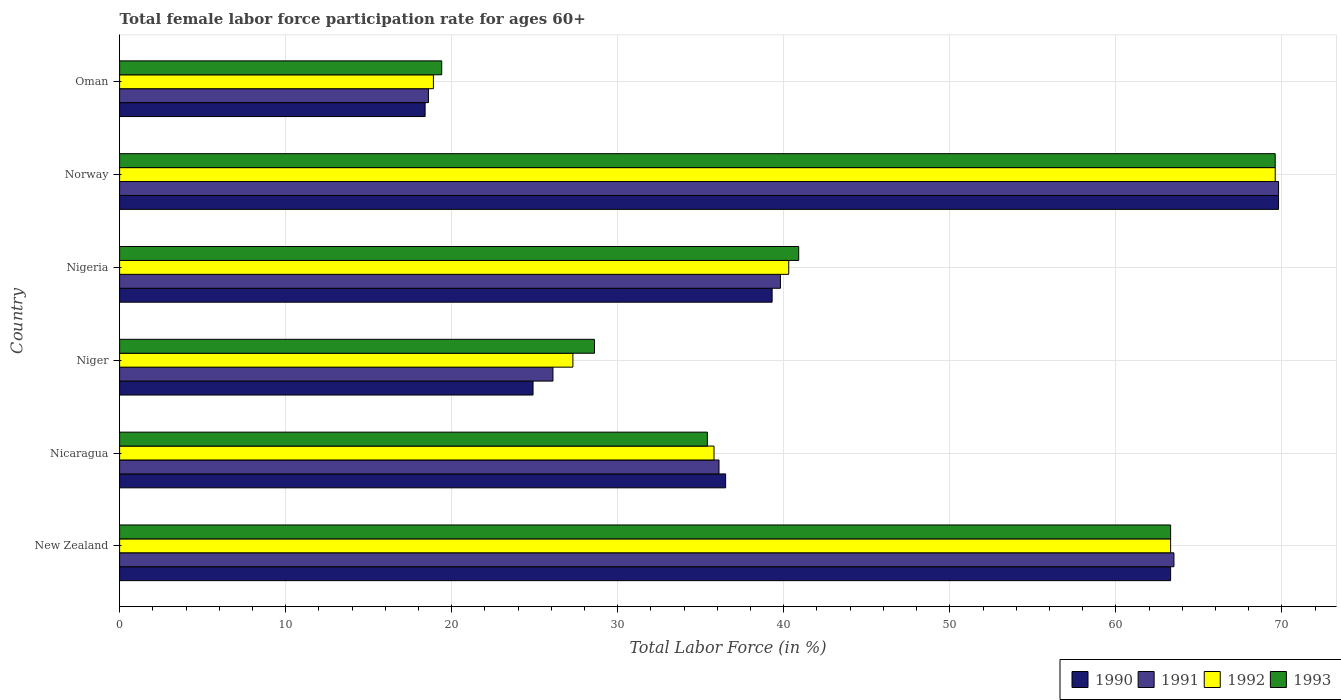Are the number of bars per tick equal to the number of legend labels?
Your answer should be very brief. Yes. How many bars are there on the 4th tick from the top?
Your answer should be very brief. 4. How many bars are there on the 1st tick from the bottom?
Offer a terse response. 4. What is the label of the 1st group of bars from the top?
Ensure brevity in your answer.  Oman. In how many cases, is the number of bars for a given country not equal to the number of legend labels?
Your response must be concise. 0. What is the female labor force participation rate in 1993 in Norway?
Provide a succinct answer. 69.6. Across all countries, what is the maximum female labor force participation rate in 1991?
Provide a succinct answer. 69.8. Across all countries, what is the minimum female labor force participation rate in 1993?
Provide a short and direct response. 19.4. In which country was the female labor force participation rate in 1990 minimum?
Your response must be concise. Oman. What is the total female labor force participation rate in 1991 in the graph?
Your answer should be very brief. 253.9. What is the difference between the female labor force participation rate in 1992 in New Zealand and that in Oman?
Make the answer very short. 44.4. What is the difference between the female labor force participation rate in 1993 in New Zealand and the female labor force participation rate in 1990 in Norway?
Your answer should be very brief. -6.5. What is the average female labor force participation rate in 1993 per country?
Provide a short and direct response. 42.87. What is the difference between the female labor force participation rate in 1993 and female labor force participation rate in 1992 in Nicaragua?
Provide a succinct answer. -0.4. In how many countries, is the female labor force participation rate in 1990 greater than 2 %?
Give a very brief answer. 6. What is the ratio of the female labor force participation rate in 1993 in Niger to that in Nigeria?
Provide a short and direct response. 0.7. Is the female labor force participation rate in 1992 in Niger less than that in Oman?
Your answer should be very brief. No. Is the difference between the female labor force participation rate in 1993 in Norway and Oman greater than the difference between the female labor force participation rate in 1992 in Norway and Oman?
Provide a succinct answer. No. What is the difference between the highest and the second highest female labor force participation rate in 1993?
Offer a very short reply. 6.3. What is the difference between the highest and the lowest female labor force participation rate in 1990?
Keep it short and to the point. 51.4. Is the sum of the female labor force participation rate in 1990 in New Zealand and Oman greater than the maximum female labor force participation rate in 1993 across all countries?
Ensure brevity in your answer.  Yes. Is it the case that in every country, the sum of the female labor force participation rate in 1991 and female labor force participation rate in 1990 is greater than the sum of female labor force participation rate in 1993 and female labor force participation rate in 1992?
Keep it short and to the point. No. What does the 1st bar from the top in Nicaragua represents?
Provide a short and direct response. 1993. How many bars are there?
Your answer should be compact. 24. How many countries are there in the graph?
Your answer should be very brief. 6. Where does the legend appear in the graph?
Your response must be concise. Bottom right. How many legend labels are there?
Your answer should be very brief. 4. What is the title of the graph?
Offer a terse response. Total female labor force participation rate for ages 60+. Does "1967" appear as one of the legend labels in the graph?
Offer a very short reply. No. What is the label or title of the X-axis?
Make the answer very short. Total Labor Force (in %). What is the label or title of the Y-axis?
Ensure brevity in your answer.  Country. What is the Total Labor Force (in %) of 1990 in New Zealand?
Provide a succinct answer. 63.3. What is the Total Labor Force (in %) in 1991 in New Zealand?
Ensure brevity in your answer.  63.5. What is the Total Labor Force (in %) in 1992 in New Zealand?
Offer a very short reply. 63.3. What is the Total Labor Force (in %) of 1993 in New Zealand?
Make the answer very short. 63.3. What is the Total Labor Force (in %) of 1990 in Nicaragua?
Offer a very short reply. 36.5. What is the Total Labor Force (in %) of 1991 in Nicaragua?
Your answer should be very brief. 36.1. What is the Total Labor Force (in %) in 1992 in Nicaragua?
Ensure brevity in your answer.  35.8. What is the Total Labor Force (in %) in 1993 in Nicaragua?
Your answer should be compact. 35.4. What is the Total Labor Force (in %) in 1990 in Niger?
Keep it short and to the point. 24.9. What is the Total Labor Force (in %) of 1991 in Niger?
Your response must be concise. 26.1. What is the Total Labor Force (in %) in 1992 in Niger?
Ensure brevity in your answer.  27.3. What is the Total Labor Force (in %) in 1993 in Niger?
Ensure brevity in your answer.  28.6. What is the Total Labor Force (in %) of 1990 in Nigeria?
Give a very brief answer. 39.3. What is the Total Labor Force (in %) of 1991 in Nigeria?
Offer a very short reply. 39.8. What is the Total Labor Force (in %) in 1992 in Nigeria?
Your answer should be compact. 40.3. What is the Total Labor Force (in %) of 1993 in Nigeria?
Your answer should be very brief. 40.9. What is the Total Labor Force (in %) in 1990 in Norway?
Offer a terse response. 69.8. What is the Total Labor Force (in %) in 1991 in Norway?
Ensure brevity in your answer.  69.8. What is the Total Labor Force (in %) in 1992 in Norway?
Make the answer very short. 69.6. What is the Total Labor Force (in %) of 1993 in Norway?
Your answer should be compact. 69.6. What is the Total Labor Force (in %) in 1990 in Oman?
Your response must be concise. 18.4. What is the Total Labor Force (in %) of 1991 in Oman?
Provide a short and direct response. 18.6. What is the Total Labor Force (in %) in 1992 in Oman?
Keep it short and to the point. 18.9. What is the Total Labor Force (in %) of 1993 in Oman?
Give a very brief answer. 19.4. Across all countries, what is the maximum Total Labor Force (in %) in 1990?
Your response must be concise. 69.8. Across all countries, what is the maximum Total Labor Force (in %) of 1991?
Keep it short and to the point. 69.8. Across all countries, what is the maximum Total Labor Force (in %) in 1992?
Give a very brief answer. 69.6. Across all countries, what is the maximum Total Labor Force (in %) in 1993?
Your answer should be compact. 69.6. Across all countries, what is the minimum Total Labor Force (in %) in 1990?
Your answer should be very brief. 18.4. Across all countries, what is the minimum Total Labor Force (in %) in 1991?
Your answer should be very brief. 18.6. Across all countries, what is the minimum Total Labor Force (in %) of 1992?
Your response must be concise. 18.9. Across all countries, what is the minimum Total Labor Force (in %) in 1993?
Ensure brevity in your answer.  19.4. What is the total Total Labor Force (in %) of 1990 in the graph?
Your answer should be compact. 252.2. What is the total Total Labor Force (in %) of 1991 in the graph?
Offer a terse response. 253.9. What is the total Total Labor Force (in %) in 1992 in the graph?
Provide a succinct answer. 255.2. What is the total Total Labor Force (in %) of 1993 in the graph?
Your answer should be very brief. 257.2. What is the difference between the Total Labor Force (in %) of 1990 in New Zealand and that in Nicaragua?
Provide a short and direct response. 26.8. What is the difference between the Total Labor Force (in %) of 1991 in New Zealand and that in Nicaragua?
Provide a succinct answer. 27.4. What is the difference between the Total Labor Force (in %) of 1993 in New Zealand and that in Nicaragua?
Make the answer very short. 27.9. What is the difference between the Total Labor Force (in %) of 1990 in New Zealand and that in Niger?
Offer a very short reply. 38.4. What is the difference between the Total Labor Force (in %) in 1991 in New Zealand and that in Niger?
Your answer should be very brief. 37.4. What is the difference between the Total Labor Force (in %) in 1993 in New Zealand and that in Niger?
Make the answer very short. 34.7. What is the difference between the Total Labor Force (in %) of 1990 in New Zealand and that in Nigeria?
Your response must be concise. 24. What is the difference between the Total Labor Force (in %) of 1991 in New Zealand and that in Nigeria?
Your answer should be very brief. 23.7. What is the difference between the Total Labor Force (in %) of 1992 in New Zealand and that in Nigeria?
Ensure brevity in your answer.  23. What is the difference between the Total Labor Force (in %) of 1993 in New Zealand and that in Nigeria?
Make the answer very short. 22.4. What is the difference between the Total Labor Force (in %) in 1993 in New Zealand and that in Norway?
Offer a very short reply. -6.3. What is the difference between the Total Labor Force (in %) in 1990 in New Zealand and that in Oman?
Make the answer very short. 44.9. What is the difference between the Total Labor Force (in %) in 1991 in New Zealand and that in Oman?
Your response must be concise. 44.9. What is the difference between the Total Labor Force (in %) in 1992 in New Zealand and that in Oman?
Provide a succinct answer. 44.4. What is the difference between the Total Labor Force (in %) in 1993 in New Zealand and that in Oman?
Offer a very short reply. 43.9. What is the difference between the Total Labor Force (in %) in 1990 in Nicaragua and that in Nigeria?
Offer a terse response. -2.8. What is the difference between the Total Labor Force (in %) in 1990 in Nicaragua and that in Norway?
Keep it short and to the point. -33.3. What is the difference between the Total Labor Force (in %) of 1991 in Nicaragua and that in Norway?
Your answer should be compact. -33.7. What is the difference between the Total Labor Force (in %) of 1992 in Nicaragua and that in Norway?
Your answer should be very brief. -33.8. What is the difference between the Total Labor Force (in %) of 1993 in Nicaragua and that in Norway?
Your answer should be compact. -34.2. What is the difference between the Total Labor Force (in %) in 1990 in Niger and that in Nigeria?
Offer a terse response. -14.4. What is the difference between the Total Labor Force (in %) in 1991 in Niger and that in Nigeria?
Make the answer very short. -13.7. What is the difference between the Total Labor Force (in %) in 1990 in Niger and that in Norway?
Give a very brief answer. -44.9. What is the difference between the Total Labor Force (in %) of 1991 in Niger and that in Norway?
Provide a short and direct response. -43.7. What is the difference between the Total Labor Force (in %) of 1992 in Niger and that in Norway?
Keep it short and to the point. -42.3. What is the difference between the Total Labor Force (in %) of 1993 in Niger and that in Norway?
Your answer should be very brief. -41. What is the difference between the Total Labor Force (in %) in 1990 in Niger and that in Oman?
Give a very brief answer. 6.5. What is the difference between the Total Labor Force (in %) in 1991 in Niger and that in Oman?
Your response must be concise. 7.5. What is the difference between the Total Labor Force (in %) of 1992 in Niger and that in Oman?
Ensure brevity in your answer.  8.4. What is the difference between the Total Labor Force (in %) of 1990 in Nigeria and that in Norway?
Provide a succinct answer. -30.5. What is the difference between the Total Labor Force (in %) of 1992 in Nigeria and that in Norway?
Your response must be concise. -29.3. What is the difference between the Total Labor Force (in %) of 1993 in Nigeria and that in Norway?
Your response must be concise. -28.7. What is the difference between the Total Labor Force (in %) in 1990 in Nigeria and that in Oman?
Offer a terse response. 20.9. What is the difference between the Total Labor Force (in %) in 1991 in Nigeria and that in Oman?
Provide a short and direct response. 21.2. What is the difference between the Total Labor Force (in %) in 1992 in Nigeria and that in Oman?
Offer a terse response. 21.4. What is the difference between the Total Labor Force (in %) of 1990 in Norway and that in Oman?
Your answer should be very brief. 51.4. What is the difference between the Total Labor Force (in %) in 1991 in Norway and that in Oman?
Provide a short and direct response. 51.2. What is the difference between the Total Labor Force (in %) in 1992 in Norway and that in Oman?
Offer a terse response. 50.7. What is the difference between the Total Labor Force (in %) of 1993 in Norway and that in Oman?
Provide a succinct answer. 50.2. What is the difference between the Total Labor Force (in %) of 1990 in New Zealand and the Total Labor Force (in %) of 1991 in Nicaragua?
Keep it short and to the point. 27.2. What is the difference between the Total Labor Force (in %) of 1990 in New Zealand and the Total Labor Force (in %) of 1992 in Nicaragua?
Keep it short and to the point. 27.5. What is the difference between the Total Labor Force (in %) in 1990 in New Zealand and the Total Labor Force (in %) in 1993 in Nicaragua?
Keep it short and to the point. 27.9. What is the difference between the Total Labor Force (in %) of 1991 in New Zealand and the Total Labor Force (in %) of 1992 in Nicaragua?
Ensure brevity in your answer.  27.7. What is the difference between the Total Labor Force (in %) in 1991 in New Zealand and the Total Labor Force (in %) in 1993 in Nicaragua?
Keep it short and to the point. 28.1. What is the difference between the Total Labor Force (in %) in 1992 in New Zealand and the Total Labor Force (in %) in 1993 in Nicaragua?
Your answer should be compact. 27.9. What is the difference between the Total Labor Force (in %) of 1990 in New Zealand and the Total Labor Force (in %) of 1991 in Niger?
Your response must be concise. 37.2. What is the difference between the Total Labor Force (in %) of 1990 in New Zealand and the Total Labor Force (in %) of 1993 in Niger?
Offer a terse response. 34.7. What is the difference between the Total Labor Force (in %) of 1991 in New Zealand and the Total Labor Force (in %) of 1992 in Niger?
Your response must be concise. 36.2. What is the difference between the Total Labor Force (in %) of 1991 in New Zealand and the Total Labor Force (in %) of 1993 in Niger?
Ensure brevity in your answer.  34.9. What is the difference between the Total Labor Force (in %) in 1992 in New Zealand and the Total Labor Force (in %) in 1993 in Niger?
Offer a very short reply. 34.7. What is the difference between the Total Labor Force (in %) of 1990 in New Zealand and the Total Labor Force (in %) of 1992 in Nigeria?
Your response must be concise. 23. What is the difference between the Total Labor Force (in %) of 1990 in New Zealand and the Total Labor Force (in %) of 1993 in Nigeria?
Your answer should be very brief. 22.4. What is the difference between the Total Labor Force (in %) of 1991 in New Zealand and the Total Labor Force (in %) of 1992 in Nigeria?
Give a very brief answer. 23.2. What is the difference between the Total Labor Force (in %) of 1991 in New Zealand and the Total Labor Force (in %) of 1993 in Nigeria?
Your answer should be very brief. 22.6. What is the difference between the Total Labor Force (in %) of 1992 in New Zealand and the Total Labor Force (in %) of 1993 in Nigeria?
Give a very brief answer. 22.4. What is the difference between the Total Labor Force (in %) in 1990 in New Zealand and the Total Labor Force (in %) in 1991 in Norway?
Your answer should be compact. -6.5. What is the difference between the Total Labor Force (in %) of 1990 in New Zealand and the Total Labor Force (in %) of 1993 in Norway?
Offer a very short reply. -6.3. What is the difference between the Total Labor Force (in %) of 1991 in New Zealand and the Total Labor Force (in %) of 1993 in Norway?
Your answer should be compact. -6.1. What is the difference between the Total Labor Force (in %) of 1990 in New Zealand and the Total Labor Force (in %) of 1991 in Oman?
Your answer should be very brief. 44.7. What is the difference between the Total Labor Force (in %) in 1990 in New Zealand and the Total Labor Force (in %) in 1992 in Oman?
Keep it short and to the point. 44.4. What is the difference between the Total Labor Force (in %) of 1990 in New Zealand and the Total Labor Force (in %) of 1993 in Oman?
Offer a terse response. 43.9. What is the difference between the Total Labor Force (in %) in 1991 in New Zealand and the Total Labor Force (in %) in 1992 in Oman?
Provide a succinct answer. 44.6. What is the difference between the Total Labor Force (in %) in 1991 in New Zealand and the Total Labor Force (in %) in 1993 in Oman?
Make the answer very short. 44.1. What is the difference between the Total Labor Force (in %) in 1992 in New Zealand and the Total Labor Force (in %) in 1993 in Oman?
Offer a terse response. 43.9. What is the difference between the Total Labor Force (in %) of 1990 in Nicaragua and the Total Labor Force (in %) of 1991 in Niger?
Ensure brevity in your answer.  10.4. What is the difference between the Total Labor Force (in %) in 1990 in Nicaragua and the Total Labor Force (in %) in 1992 in Niger?
Keep it short and to the point. 9.2. What is the difference between the Total Labor Force (in %) of 1991 in Nicaragua and the Total Labor Force (in %) of 1992 in Niger?
Your answer should be very brief. 8.8. What is the difference between the Total Labor Force (in %) of 1991 in Nicaragua and the Total Labor Force (in %) of 1993 in Niger?
Keep it short and to the point. 7.5. What is the difference between the Total Labor Force (in %) in 1990 in Nicaragua and the Total Labor Force (in %) in 1991 in Nigeria?
Make the answer very short. -3.3. What is the difference between the Total Labor Force (in %) of 1990 in Nicaragua and the Total Labor Force (in %) of 1993 in Nigeria?
Give a very brief answer. -4.4. What is the difference between the Total Labor Force (in %) in 1991 in Nicaragua and the Total Labor Force (in %) in 1993 in Nigeria?
Your answer should be very brief. -4.8. What is the difference between the Total Labor Force (in %) of 1992 in Nicaragua and the Total Labor Force (in %) of 1993 in Nigeria?
Give a very brief answer. -5.1. What is the difference between the Total Labor Force (in %) in 1990 in Nicaragua and the Total Labor Force (in %) in 1991 in Norway?
Offer a terse response. -33.3. What is the difference between the Total Labor Force (in %) in 1990 in Nicaragua and the Total Labor Force (in %) in 1992 in Norway?
Offer a terse response. -33.1. What is the difference between the Total Labor Force (in %) of 1990 in Nicaragua and the Total Labor Force (in %) of 1993 in Norway?
Offer a terse response. -33.1. What is the difference between the Total Labor Force (in %) in 1991 in Nicaragua and the Total Labor Force (in %) in 1992 in Norway?
Give a very brief answer. -33.5. What is the difference between the Total Labor Force (in %) in 1991 in Nicaragua and the Total Labor Force (in %) in 1993 in Norway?
Your response must be concise. -33.5. What is the difference between the Total Labor Force (in %) in 1992 in Nicaragua and the Total Labor Force (in %) in 1993 in Norway?
Your response must be concise. -33.8. What is the difference between the Total Labor Force (in %) of 1990 in Nicaragua and the Total Labor Force (in %) of 1991 in Oman?
Offer a terse response. 17.9. What is the difference between the Total Labor Force (in %) of 1990 in Nicaragua and the Total Labor Force (in %) of 1993 in Oman?
Your answer should be compact. 17.1. What is the difference between the Total Labor Force (in %) in 1991 in Nicaragua and the Total Labor Force (in %) in 1992 in Oman?
Your answer should be compact. 17.2. What is the difference between the Total Labor Force (in %) of 1991 in Nicaragua and the Total Labor Force (in %) of 1993 in Oman?
Provide a short and direct response. 16.7. What is the difference between the Total Labor Force (in %) in 1990 in Niger and the Total Labor Force (in %) in 1991 in Nigeria?
Give a very brief answer. -14.9. What is the difference between the Total Labor Force (in %) of 1990 in Niger and the Total Labor Force (in %) of 1992 in Nigeria?
Provide a short and direct response. -15.4. What is the difference between the Total Labor Force (in %) in 1991 in Niger and the Total Labor Force (in %) in 1993 in Nigeria?
Offer a terse response. -14.8. What is the difference between the Total Labor Force (in %) of 1992 in Niger and the Total Labor Force (in %) of 1993 in Nigeria?
Your response must be concise. -13.6. What is the difference between the Total Labor Force (in %) of 1990 in Niger and the Total Labor Force (in %) of 1991 in Norway?
Your answer should be compact. -44.9. What is the difference between the Total Labor Force (in %) in 1990 in Niger and the Total Labor Force (in %) in 1992 in Norway?
Provide a succinct answer. -44.7. What is the difference between the Total Labor Force (in %) in 1990 in Niger and the Total Labor Force (in %) in 1993 in Norway?
Offer a very short reply. -44.7. What is the difference between the Total Labor Force (in %) of 1991 in Niger and the Total Labor Force (in %) of 1992 in Norway?
Your response must be concise. -43.5. What is the difference between the Total Labor Force (in %) in 1991 in Niger and the Total Labor Force (in %) in 1993 in Norway?
Give a very brief answer. -43.5. What is the difference between the Total Labor Force (in %) in 1992 in Niger and the Total Labor Force (in %) in 1993 in Norway?
Make the answer very short. -42.3. What is the difference between the Total Labor Force (in %) of 1990 in Niger and the Total Labor Force (in %) of 1991 in Oman?
Provide a short and direct response. 6.3. What is the difference between the Total Labor Force (in %) in 1990 in Niger and the Total Labor Force (in %) in 1993 in Oman?
Offer a very short reply. 5.5. What is the difference between the Total Labor Force (in %) of 1991 in Niger and the Total Labor Force (in %) of 1992 in Oman?
Provide a short and direct response. 7.2. What is the difference between the Total Labor Force (in %) of 1990 in Nigeria and the Total Labor Force (in %) of 1991 in Norway?
Your response must be concise. -30.5. What is the difference between the Total Labor Force (in %) in 1990 in Nigeria and the Total Labor Force (in %) in 1992 in Norway?
Offer a very short reply. -30.3. What is the difference between the Total Labor Force (in %) of 1990 in Nigeria and the Total Labor Force (in %) of 1993 in Norway?
Make the answer very short. -30.3. What is the difference between the Total Labor Force (in %) in 1991 in Nigeria and the Total Labor Force (in %) in 1992 in Norway?
Give a very brief answer. -29.8. What is the difference between the Total Labor Force (in %) of 1991 in Nigeria and the Total Labor Force (in %) of 1993 in Norway?
Your answer should be very brief. -29.8. What is the difference between the Total Labor Force (in %) of 1992 in Nigeria and the Total Labor Force (in %) of 1993 in Norway?
Your answer should be compact. -29.3. What is the difference between the Total Labor Force (in %) in 1990 in Nigeria and the Total Labor Force (in %) in 1991 in Oman?
Provide a succinct answer. 20.7. What is the difference between the Total Labor Force (in %) of 1990 in Nigeria and the Total Labor Force (in %) of 1992 in Oman?
Ensure brevity in your answer.  20.4. What is the difference between the Total Labor Force (in %) of 1990 in Nigeria and the Total Labor Force (in %) of 1993 in Oman?
Offer a very short reply. 19.9. What is the difference between the Total Labor Force (in %) in 1991 in Nigeria and the Total Labor Force (in %) in 1992 in Oman?
Your response must be concise. 20.9. What is the difference between the Total Labor Force (in %) of 1991 in Nigeria and the Total Labor Force (in %) of 1993 in Oman?
Ensure brevity in your answer.  20.4. What is the difference between the Total Labor Force (in %) of 1992 in Nigeria and the Total Labor Force (in %) of 1993 in Oman?
Provide a short and direct response. 20.9. What is the difference between the Total Labor Force (in %) of 1990 in Norway and the Total Labor Force (in %) of 1991 in Oman?
Your answer should be compact. 51.2. What is the difference between the Total Labor Force (in %) in 1990 in Norway and the Total Labor Force (in %) in 1992 in Oman?
Provide a short and direct response. 50.9. What is the difference between the Total Labor Force (in %) of 1990 in Norway and the Total Labor Force (in %) of 1993 in Oman?
Keep it short and to the point. 50.4. What is the difference between the Total Labor Force (in %) of 1991 in Norway and the Total Labor Force (in %) of 1992 in Oman?
Your answer should be compact. 50.9. What is the difference between the Total Labor Force (in %) in 1991 in Norway and the Total Labor Force (in %) in 1993 in Oman?
Offer a terse response. 50.4. What is the difference between the Total Labor Force (in %) of 1992 in Norway and the Total Labor Force (in %) of 1993 in Oman?
Your response must be concise. 50.2. What is the average Total Labor Force (in %) of 1990 per country?
Give a very brief answer. 42.03. What is the average Total Labor Force (in %) in 1991 per country?
Provide a short and direct response. 42.32. What is the average Total Labor Force (in %) of 1992 per country?
Ensure brevity in your answer.  42.53. What is the average Total Labor Force (in %) in 1993 per country?
Your response must be concise. 42.87. What is the difference between the Total Labor Force (in %) in 1990 and Total Labor Force (in %) in 1991 in New Zealand?
Keep it short and to the point. -0.2. What is the difference between the Total Labor Force (in %) in 1991 and Total Labor Force (in %) in 1992 in New Zealand?
Your response must be concise. 0.2. What is the difference between the Total Labor Force (in %) in 1991 and Total Labor Force (in %) in 1993 in New Zealand?
Keep it short and to the point. 0.2. What is the difference between the Total Labor Force (in %) of 1992 and Total Labor Force (in %) of 1993 in New Zealand?
Your answer should be very brief. 0. What is the difference between the Total Labor Force (in %) in 1990 and Total Labor Force (in %) in 1991 in Nicaragua?
Keep it short and to the point. 0.4. What is the difference between the Total Labor Force (in %) of 1990 and Total Labor Force (in %) of 1993 in Nicaragua?
Offer a very short reply. 1.1. What is the difference between the Total Labor Force (in %) in 1991 and Total Labor Force (in %) in 1993 in Nicaragua?
Offer a very short reply. 0.7. What is the difference between the Total Labor Force (in %) of 1991 and Total Labor Force (in %) of 1993 in Niger?
Your answer should be compact. -2.5. What is the difference between the Total Labor Force (in %) in 1990 and Total Labor Force (in %) in 1991 in Nigeria?
Make the answer very short. -0.5. What is the difference between the Total Labor Force (in %) of 1990 and Total Labor Force (in %) of 1992 in Nigeria?
Your answer should be compact. -1. What is the difference between the Total Labor Force (in %) in 1990 and Total Labor Force (in %) in 1993 in Nigeria?
Your response must be concise. -1.6. What is the difference between the Total Labor Force (in %) in 1991 and Total Labor Force (in %) in 1992 in Nigeria?
Your answer should be compact. -0.5. What is the difference between the Total Labor Force (in %) in 1991 and Total Labor Force (in %) in 1993 in Nigeria?
Provide a succinct answer. -1.1. What is the difference between the Total Labor Force (in %) of 1992 and Total Labor Force (in %) of 1993 in Nigeria?
Provide a short and direct response. -0.6. What is the difference between the Total Labor Force (in %) of 1990 and Total Labor Force (in %) of 1991 in Norway?
Offer a terse response. 0. What is the difference between the Total Labor Force (in %) of 1990 and Total Labor Force (in %) of 1992 in Norway?
Your answer should be compact. 0.2. What is the difference between the Total Labor Force (in %) of 1990 and Total Labor Force (in %) of 1993 in Norway?
Give a very brief answer. 0.2. What is the difference between the Total Labor Force (in %) of 1991 and Total Labor Force (in %) of 1992 in Norway?
Your answer should be very brief. 0.2. What is the difference between the Total Labor Force (in %) in 1991 and Total Labor Force (in %) in 1993 in Norway?
Your answer should be compact. 0.2. What is the difference between the Total Labor Force (in %) in 1992 and Total Labor Force (in %) in 1993 in Norway?
Offer a very short reply. 0. What is the difference between the Total Labor Force (in %) of 1991 and Total Labor Force (in %) of 1992 in Oman?
Give a very brief answer. -0.3. What is the difference between the Total Labor Force (in %) of 1991 and Total Labor Force (in %) of 1993 in Oman?
Provide a succinct answer. -0.8. What is the difference between the Total Labor Force (in %) of 1992 and Total Labor Force (in %) of 1993 in Oman?
Make the answer very short. -0.5. What is the ratio of the Total Labor Force (in %) of 1990 in New Zealand to that in Nicaragua?
Offer a very short reply. 1.73. What is the ratio of the Total Labor Force (in %) of 1991 in New Zealand to that in Nicaragua?
Provide a succinct answer. 1.76. What is the ratio of the Total Labor Force (in %) of 1992 in New Zealand to that in Nicaragua?
Your answer should be very brief. 1.77. What is the ratio of the Total Labor Force (in %) of 1993 in New Zealand to that in Nicaragua?
Make the answer very short. 1.79. What is the ratio of the Total Labor Force (in %) of 1990 in New Zealand to that in Niger?
Keep it short and to the point. 2.54. What is the ratio of the Total Labor Force (in %) of 1991 in New Zealand to that in Niger?
Give a very brief answer. 2.43. What is the ratio of the Total Labor Force (in %) of 1992 in New Zealand to that in Niger?
Your answer should be compact. 2.32. What is the ratio of the Total Labor Force (in %) of 1993 in New Zealand to that in Niger?
Offer a very short reply. 2.21. What is the ratio of the Total Labor Force (in %) in 1990 in New Zealand to that in Nigeria?
Ensure brevity in your answer.  1.61. What is the ratio of the Total Labor Force (in %) of 1991 in New Zealand to that in Nigeria?
Give a very brief answer. 1.6. What is the ratio of the Total Labor Force (in %) of 1992 in New Zealand to that in Nigeria?
Give a very brief answer. 1.57. What is the ratio of the Total Labor Force (in %) in 1993 in New Zealand to that in Nigeria?
Offer a very short reply. 1.55. What is the ratio of the Total Labor Force (in %) in 1990 in New Zealand to that in Norway?
Offer a very short reply. 0.91. What is the ratio of the Total Labor Force (in %) of 1991 in New Zealand to that in Norway?
Your answer should be compact. 0.91. What is the ratio of the Total Labor Force (in %) of 1992 in New Zealand to that in Norway?
Ensure brevity in your answer.  0.91. What is the ratio of the Total Labor Force (in %) of 1993 in New Zealand to that in Norway?
Your response must be concise. 0.91. What is the ratio of the Total Labor Force (in %) in 1990 in New Zealand to that in Oman?
Keep it short and to the point. 3.44. What is the ratio of the Total Labor Force (in %) of 1991 in New Zealand to that in Oman?
Give a very brief answer. 3.41. What is the ratio of the Total Labor Force (in %) in 1992 in New Zealand to that in Oman?
Your answer should be very brief. 3.35. What is the ratio of the Total Labor Force (in %) of 1993 in New Zealand to that in Oman?
Offer a very short reply. 3.26. What is the ratio of the Total Labor Force (in %) of 1990 in Nicaragua to that in Niger?
Provide a short and direct response. 1.47. What is the ratio of the Total Labor Force (in %) in 1991 in Nicaragua to that in Niger?
Provide a short and direct response. 1.38. What is the ratio of the Total Labor Force (in %) in 1992 in Nicaragua to that in Niger?
Keep it short and to the point. 1.31. What is the ratio of the Total Labor Force (in %) in 1993 in Nicaragua to that in Niger?
Your response must be concise. 1.24. What is the ratio of the Total Labor Force (in %) in 1990 in Nicaragua to that in Nigeria?
Give a very brief answer. 0.93. What is the ratio of the Total Labor Force (in %) of 1991 in Nicaragua to that in Nigeria?
Keep it short and to the point. 0.91. What is the ratio of the Total Labor Force (in %) of 1992 in Nicaragua to that in Nigeria?
Give a very brief answer. 0.89. What is the ratio of the Total Labor Force (in %) of 1993 in Nicaragua to that in Nigeria?
Your answer should be compact. 0.87. What is the ratio of the Total Labor Force (in %) in 1990 in Nicaragua to that in Norway?
Offer a terse response. 0.52. What is the ratio of the Total Labor Force (in %) in 1991 in Nicaragua to that in Norway?
Ensure brevity in your answer.  0.52. What is the ratio of the Total Labor Force (in %) in 1992 in Nicaragua to that in Norway?
Make the answer very short. 0.51. What is the ratio of the Total Labor Force (in %) of 1993 in Nicaragua to that in Norway?
Offer a very short reply. 0.51. What is the ratio of the Total Labor Force (in %) of 1990 in Nicaragua to that in Oman?
Make the answer very short. 1.98. What is the ratio of the Total Labor Force (in %) of 1991 in Nicaragua to that in Oman?
Provide a short and direct response. 1.94. What is the ratio of the Total Labor Force (in %) in 1992 in Nicaragua to that in Oman?
Keep it short and to the point. 1.89. What is the ratio of the Total Labor Force (in %) in 1993 in Nicaragua to that in Oman?
Offer a terse response. 1.82. What is the ratio of the Total Labor Force (in %) of 1990 in Niger to that in Nigeria?
Offer a terse response. 0.63. What is the ratio of the Total Labor Force (in %) in 1991 in Niger to that in Nigeria?
Your response must be concise. 0.66. What is the ratio of the Total Labor Force (in %) in 1992 in Niger to that in Nigeria?
Provide a succinct answer. 0.68. What is the ratio of the Total Labor Force (in %) in 1993 in Niger to that in Nigeria?
Your answer should be very brief. 0.7. What is the ratio of the Total Labor Force (in %) in 1990 in Niger to that in Norway?
Provide a succinct answer. 0.36. What is the ratio of the Total Labor Force (in %) in 1991 in Niger to that in Norway?
Ensure brevity in your answer.  0.37. What is the ratio of the Total Labor Force (in %) of 1992 in Niger to that in Norway?
Keep it short and to the point. 0.39. What is the ratio of the Total Labor Force (in %) of 1993 in Niger to that in Norway?
Offer a very short reply. 0.41. What is the ratio of the Total Labor Force (in %) of 1990 in Niger to that in Oman?
Give a very brief answer. 1.35. What is the ratio of the Total Labor Force (in %) in 1991 in Niger to that in Oman?
Keep it short and to the point. 1.4. What is the ratio of the Total Labor Force (in %) of 1992 in Niger to that in Oman?
Keep it short and to the point. 1.44. What is the ratio of the Total Labor Force (in %) in 1993 in Niger to that in Oman?
Offer a very short reply. 1.47. What is the ratio of the Total Labor Force (in %) of 1990 in Nigeria to that in Norway?
Your response must be concise. 0.56. What is the ratio of the Total Labor Force (in %) of 1991 in Nigeria to that in Norway?
Offer a terse response. 0.57. What is the ratio of the Total Labor Force (in %) of 1992 in Nigeria to that in Norway?
Your answer should be very brief. 0.58. What is the ratio of the Total Labor Force (in %) of 1993 in Nigeria to that in Norway?
Ensure brevity in your answer.  0.59. What is the ratio of the Total Labor Force (in %) of 1990 in Nigeria to that in Oman?
Offer a terse response. 2.14. What is the ratio of the Total Labor Force (in %) of 1991 in Nigeria to that in Oman?
Keep it short and to the point. 2.14. What is the ratio of the Total Labor Force (in %) in 1992 in Nigeria to that in Oman?
Offer a very short reply. 2.13. What is the ratio of the Total Labor Force (in %) of 1993 in Nigeria to that in Oman?
Give a very brief answer. 2.11. What is the ratio of the Total Labor Force (in %) in 1990 in Norway to that in Oman?
Keep it short and to the point. 3.79. What is the ratio of the Total Labor Force (in %) of 1991 in Norway to that in Oman?
Provide a succinct answer. 3.75. What is the ratio of the Total Labor Force (in %) of 1992 in Norway to that in Oman?
Your answer should be compact. 3.68. What is the ratio of the Total Labor Force (in %) in 1993 in Norway to that in Oman?
Offer a terse response. 3.59. What is the difference between the highest and the second highest Total Labor Force (in %) of 1993?
Your answer should be compact. 6.3. What is the difference between the highest and the lowest Total Labor Force (in %) in 1990?
Ensure brevity in your answer.  51.4. What is the difference between the highest and the lowest Total Labor Force (in %) in 1991?
Offer a very short reply. 51.2. What is the difference between the highest and the lowest Total Labor Force (in %) in 1992?
Your response must be concise. 50.7. What is the difference between the highest and the lowest Total Labor Force (in %) in 1993?
Your answer should be very brief. 50.2. 